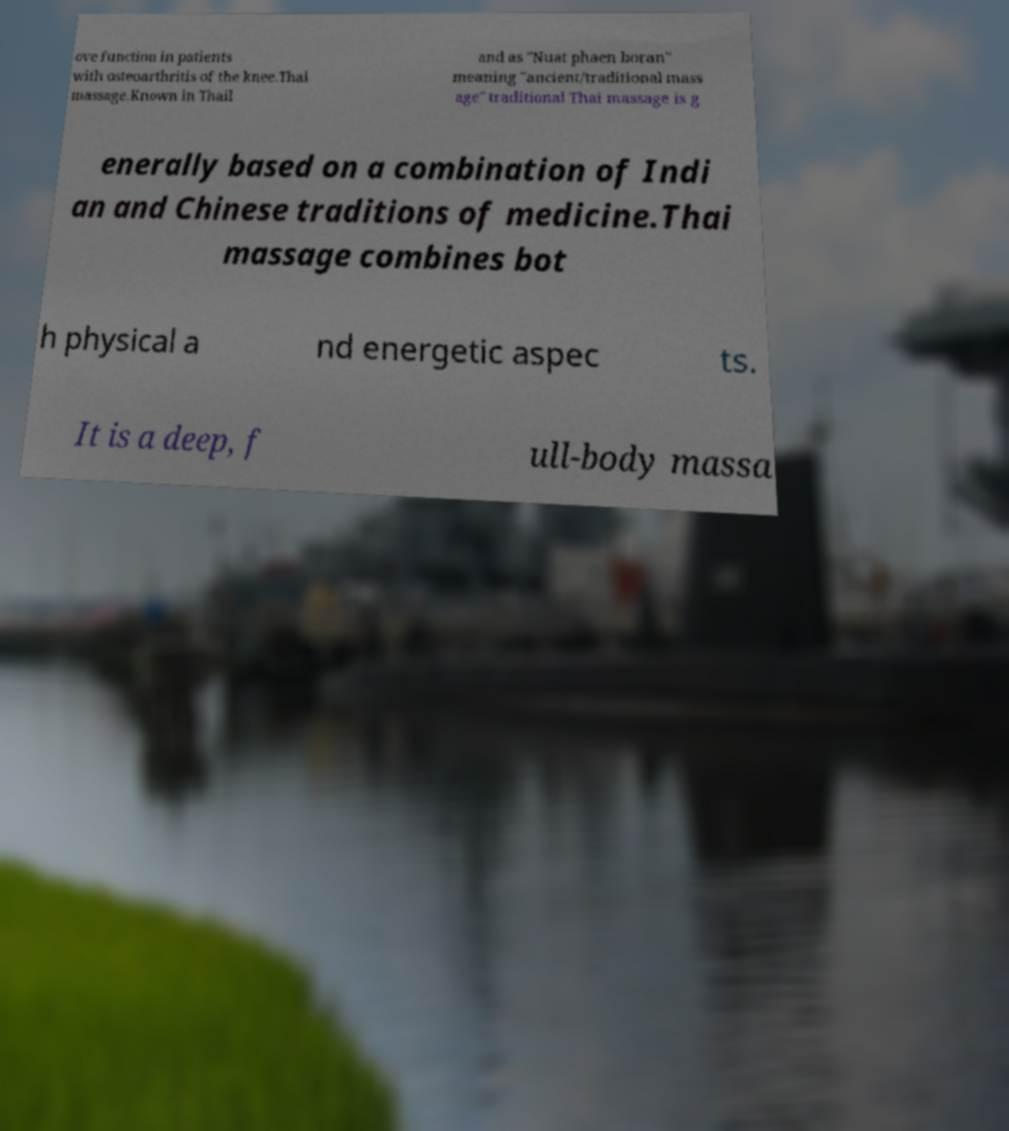Could you extract and type out the text from this image? ove function in patients with osteoarthritis of the knee.Thai massage.Known in Thail and as "Nuat phaen boran" meaning "ancient/traditional mass age" traditional Thai massage is g enerally based on a combination of Indi an and Chinese traditions of medicine.Thai massage combines bot h physical a nd energetic aspec ts. It is a deep, f ull-body massa 